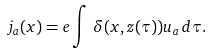<formula> <loc_0><loc_0><loc_500><loc_500>j _ { a } ( x ) = e \int \, \delta ( x , z ( \tau ) ) u _ { a } \, d \tau .</formula> 